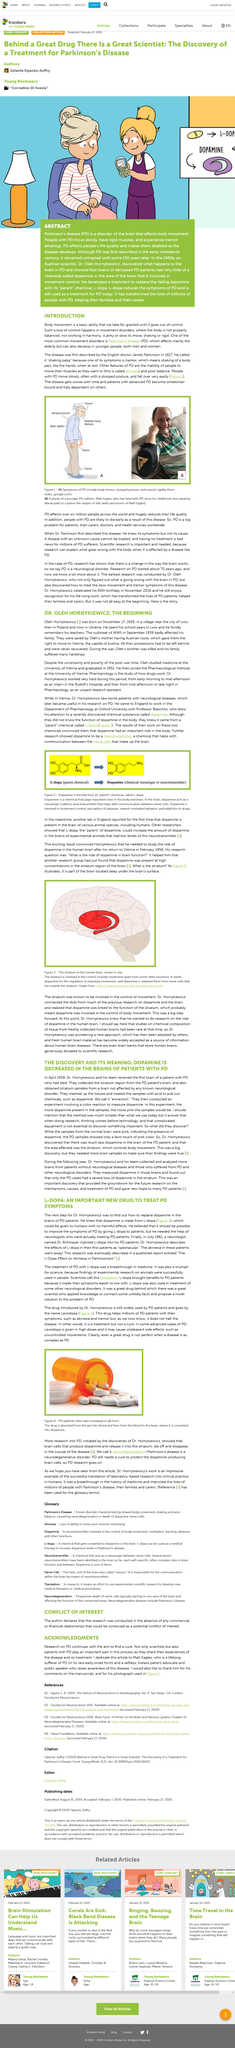Mention a couple of crucial points in this snapshot. The participation of patients with Parkinson's disease in the search for a cure is crucial because they provide valuable insights into their experiences with the disease and its treatment. Oleh Hornykiewicz, a prominent neurologist, was born near the city of Lvov. In the year 1817, an English doctor by the name of James Parkinson coined the term "shaking palsy" to describe a medical condition that is now commonly known as Parkinson's disease. In July 1961, Dr. Birkmayer tested Dr. Hornykiewicz's hypothesis on the effects of L-Dopa. The aim of research on Parkinson's disease is to find a cure. 